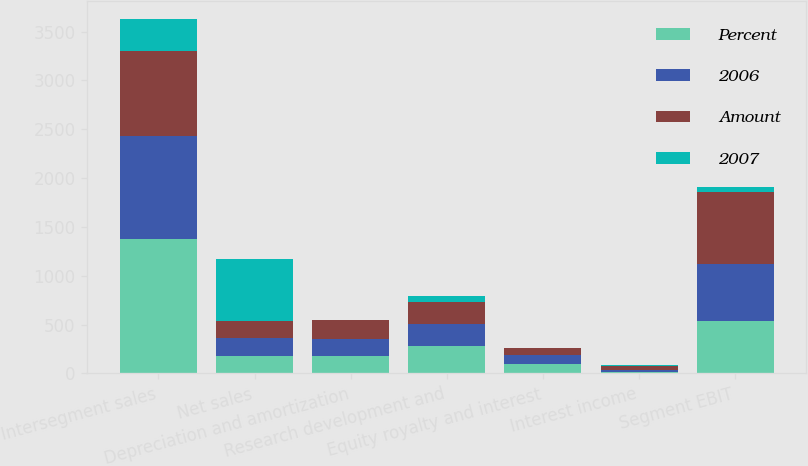<chart> <loc_0><loc_0><loc_500><loc_500><stacked_bar_chart><ecel><fcel>Intersegment sales<fcel>Net sales<fcel>Depreciation and amortization<fcel>Research development and<fcel>Equity royalty and interest<fcel>Interest income<fcel>Segment EBIT<nl><fcel>Percent<fcel>1378<fcel>180<fcel>180<fcel>286<fcel>99<fcel>10<fcel>535<nl><fcel>2006<fcel>1053<fcel>180<fcel>176<fcel>222<fcel>92<fcel>26<fcel>589<nl><fcel>Amount<fcel>871<fcel>180<fcel>192<fcel>225<fcel>67<fcel>36<fcel>733<nl><fcel>2007<fcel>325<fcel>628<fcel>4<fcel>64<fcel>7<fcel>16<fcel>54<nl></chart> 